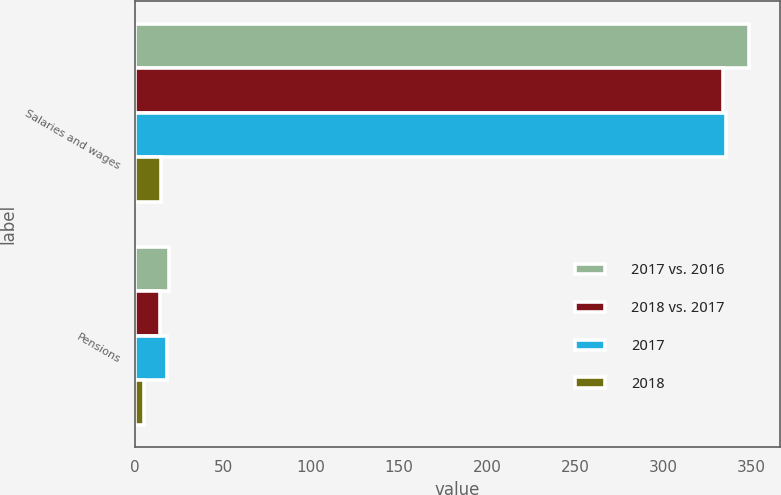Convert chart to OTSL. <chart><loc_0><loc_0><loc_500><loc_500><stacked_bar_chart><ecel><fcel>Salaries and wages<fcel>Pensions<nl><fcel>2017 vs. 2016<fcel>349<fcel>19<nl><fcel>2018 vs. 2017<fcel>334<fcel>14<nl><fcel>2017<fcel>336<fcel>18<nl><fcel>2018<fcel>15<fcel>5<nl></chart> 